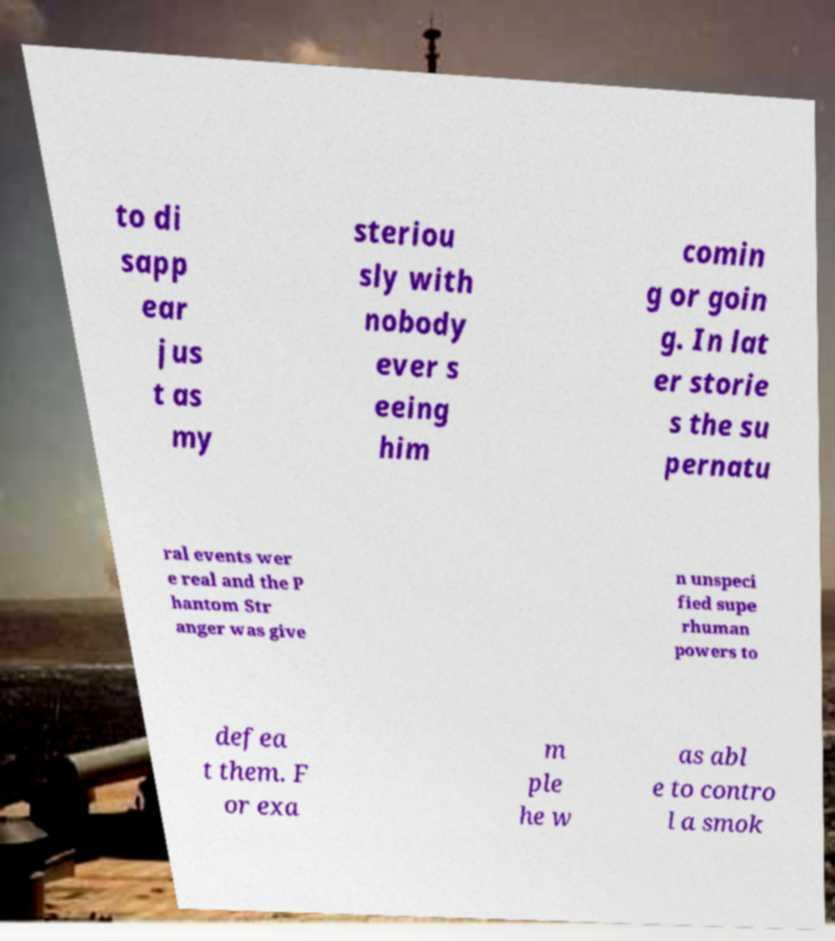Can you read and provide the text displayed in the image?This photo seems to have some interesting text. Can you extract and type it out for me? to di sapp ear jus t as my steriou sly with nobody ever s eeing him comin g or goin g. In lat er storie s the su pernatu ral events wer e real and the P hantom Str anger was give n unspeci fied supe rhuman powers to defea t them. F or exa m ple he w as abl e to contro l a smok 